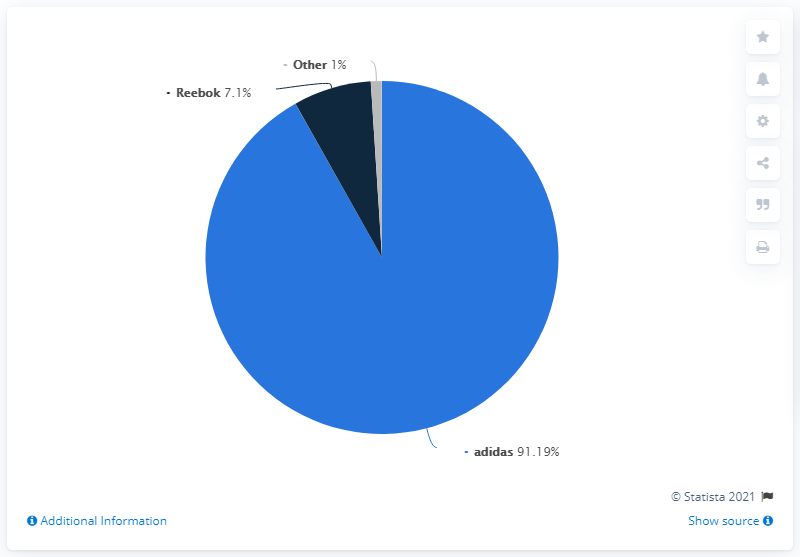List a handful of essential elements in this visual. The result of adding Adidas and Reebok is 98.29. Navy blue is the color that indicates Reebok. In 2020, the adidas brand accounted for 91.19% of the adidas Group's net sales. 